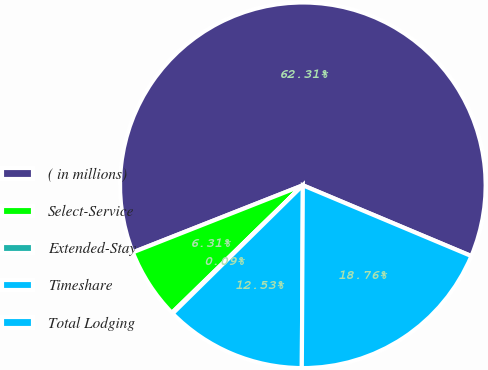<chart> <loc_0><loc_0><loc_500><loc_500><pie_chart><fcel>( in millions)<fcel>Select-Service<fcel>Extended-Stay<fcel>Timeshare<fcel>Total Lodging<nl><fcel>62.3%<fcel>6.31%<fcel>0.09%<fcel>12.53%<fcel>18.76%<nl></chart> 